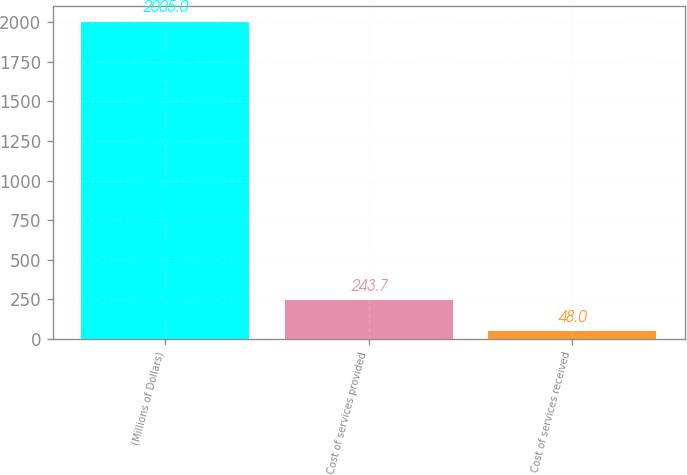Convert chart to OTSL. <chart><loc_0><loc_0><loc_500><loc_500><bar_chart><fcel>(Millions of Dollars)<fcel>Cost of services provided<fcel>Cost of services received<nl><fcel>2005<fcel>243.7<fcel>48<nl></chart> 